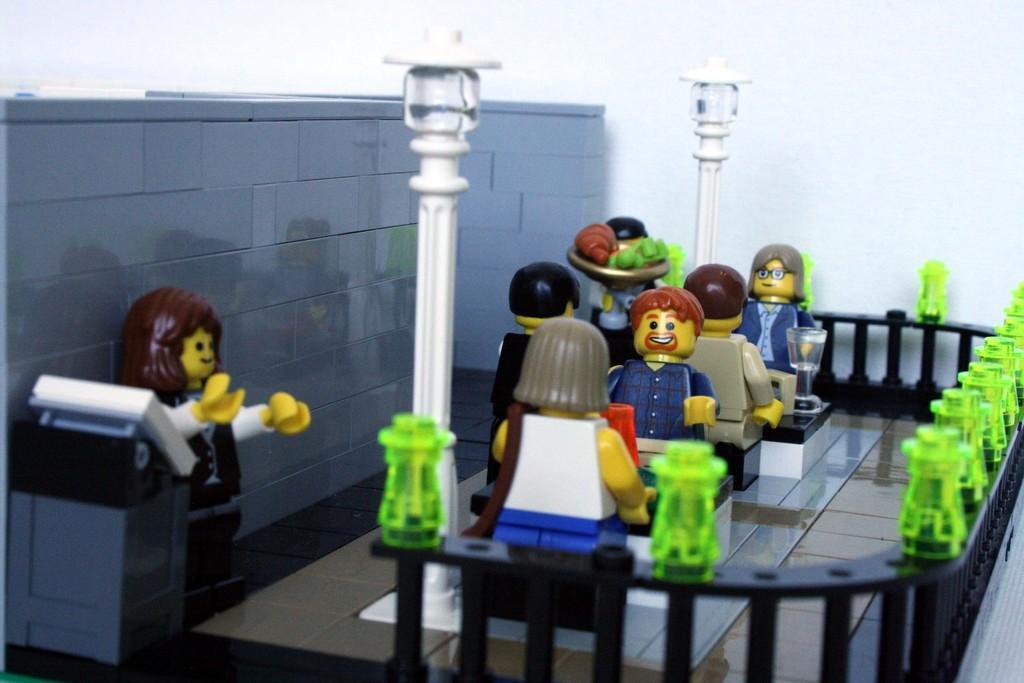Could you give a brief overview of what you see in this image? In this picture there are some toys placed. We can observe table and chairs. There are two white color poles here. There is a black color railing. In the left side there is a grey color wall. In the background there is a white color wall here. 